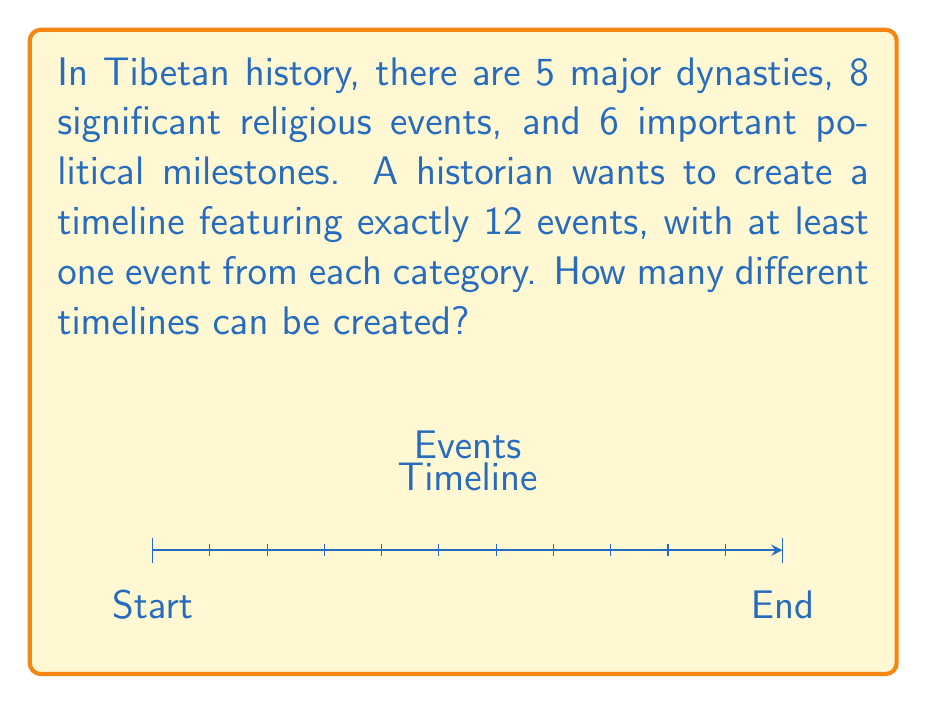Teach me how to tackle this problem. Let's approach this step-by-step using the principle of inclusion-exclusion and the stars and bars method:

1) First, we need to ensure at least one event from each category is included. Let's select one from each:
   $$5 \cdot 8 \cdot 6 = 240$$ ways to do this.

2) Now we have 3 events selected and need to choose 9 more from the remaining 16 events (5+8+6-3 = 16).

3) This is equivalent to distributing 9 indistinguishable balls (remaining event slots) into 4 distinguishable boxes (the three categories plus one "not used" category). We can use the stars and bars formula:

   $$\binom{9+4-1}{4-1} = \binom{12}{3} = 220$$

4) By the multiplication principle, the total number of ways to create the timeline is:

   $$240 \cdot 220 = 52,800$$

Therefore, there are 52,800 different possible timelines.
Answer: 52,800 